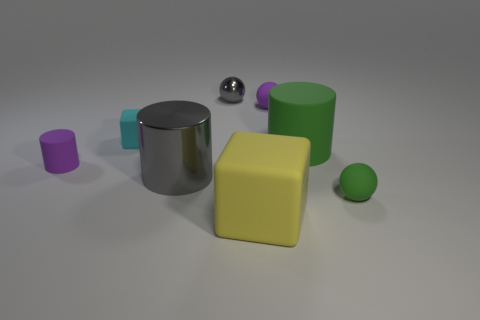How big is the purple rubber object right of the gray thing that is in front of the small gray metallic sphere?
Offer a very short reply. Small. Is the color of the tiny block the same as the large object on the right side of the yellow thing?
Provide a short and direct response. No. What material is the gray thing that is the same size as the green rubber ball?
Your response must be concise. Metal. Are there fewer green rubber balls to the right of the small cyan rubber cube than large cylinders that are behind the gray sphere?
Your response must be concise. No. What is the shape of the thing that is in front of the tiny thing that is in front of the purple cylinder?
Provide a short and direct response. Cube. Is there a gray shiny cube?
Offer a terse response. No. There is a big object that is left of the tiny gray shiny thing; what is its color?
Your response must be concise. Gray. What material is the thing that is the same color as the small rubber cylinder?
Keep it short and to the point. Rubber. Are there any small cylinders to the right of the tiny green object?
Keep it short and to the point. No. Are there more tiny matte objects than matte things?
Your answer should be compact. No. 